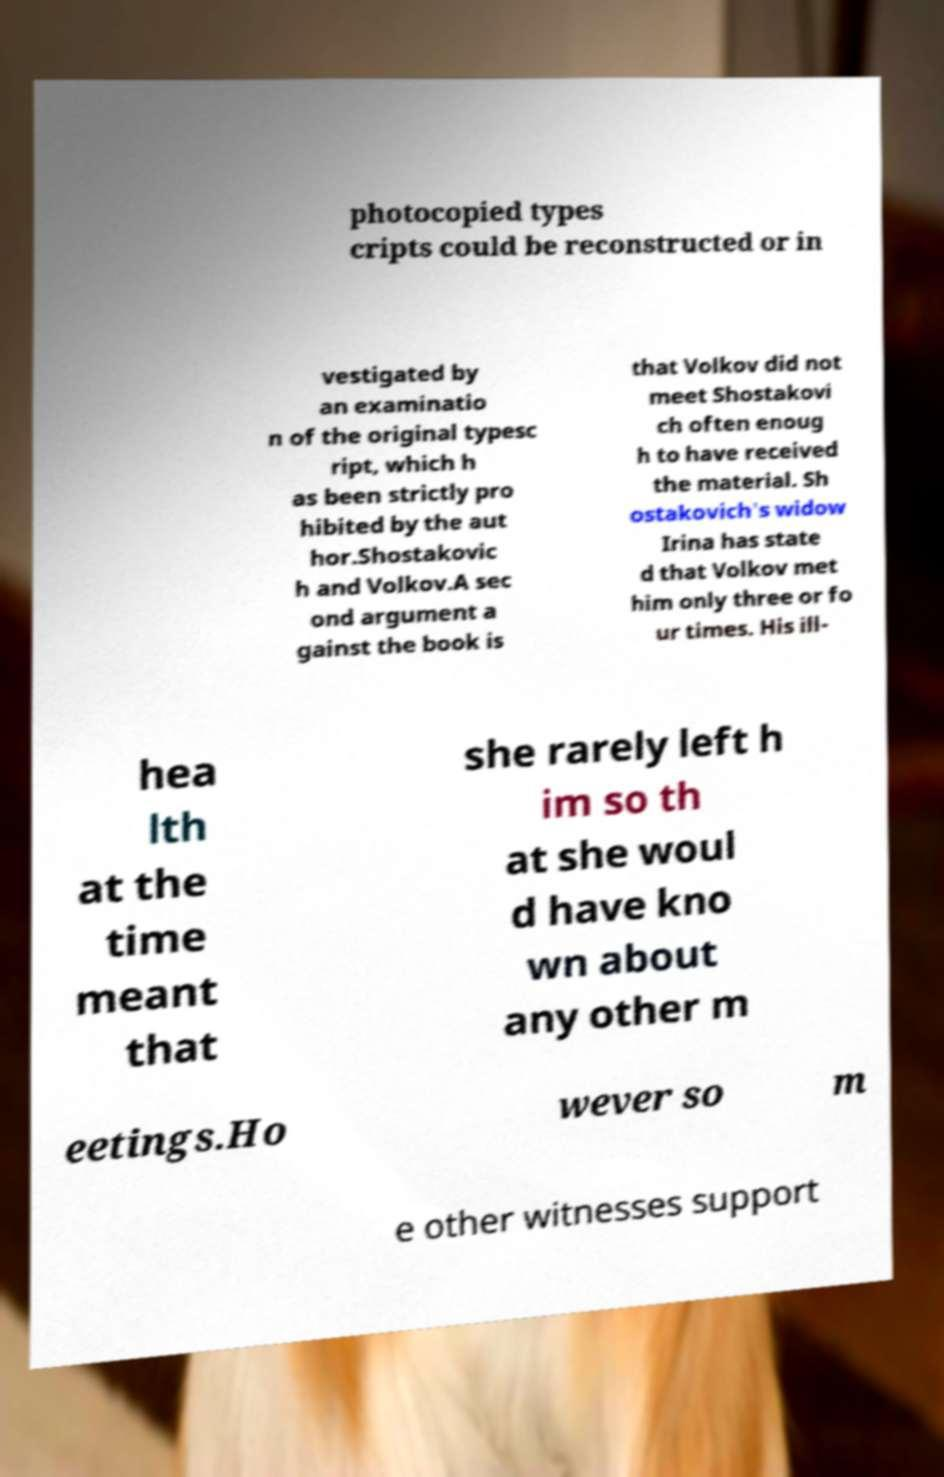I need the written content from this picture converted into text. Can you do that? photocopied types cripts could be reconstructed or in vestigated by an examinatio n of the original typesc ript, which h as been strictly pro hibited by the aut hor.Shostakovic h and Volkov.A sec ond argument a gainst the book is that Volkov did not meet Shostakovi ch often enoug h to have received the material. Sh ostakovich's widow Irina has state d that Volkov met him only three or fo ur times. His ill- hea lth at the time meant that she rarely left h im so th at she woul d have kno wn about any other m eetings.Ho wever so m e other witnesses support 